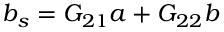<formula> <loc_0><loc_0><loc_500><loc_500>b _ { s } = G _ { 2 1 } a + G _ { 2 2 } b</formula> 